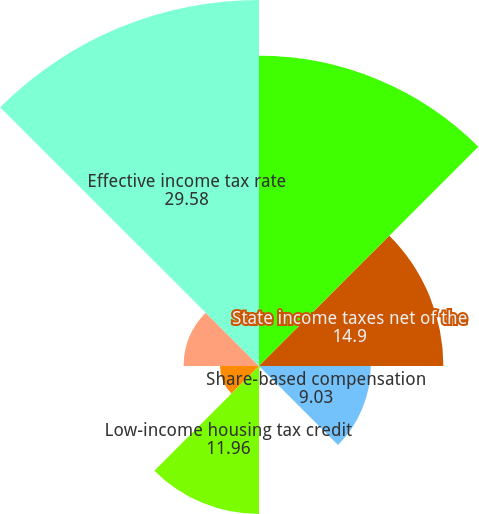<chart> <loc_0><loc_0><loc_500><loc_500><pie_chart><fcel>Federal statutory income tax<fcel>State income taxes net of the<fcel>Share-based compensation<fcel>Meals and entertainment<fcel>Low-income housing tax credit<fcel>Tax-exempt interest income<fcel>Other net<fcel>Effective income tax rate<nl><fcel>25.07%<fcel>14.9%<fcel>9.03%<fcel>0.21%<fcel>11.96%<fcel>3.15%<fcel>6.09%<fcel>29.58%<nl></chart> 